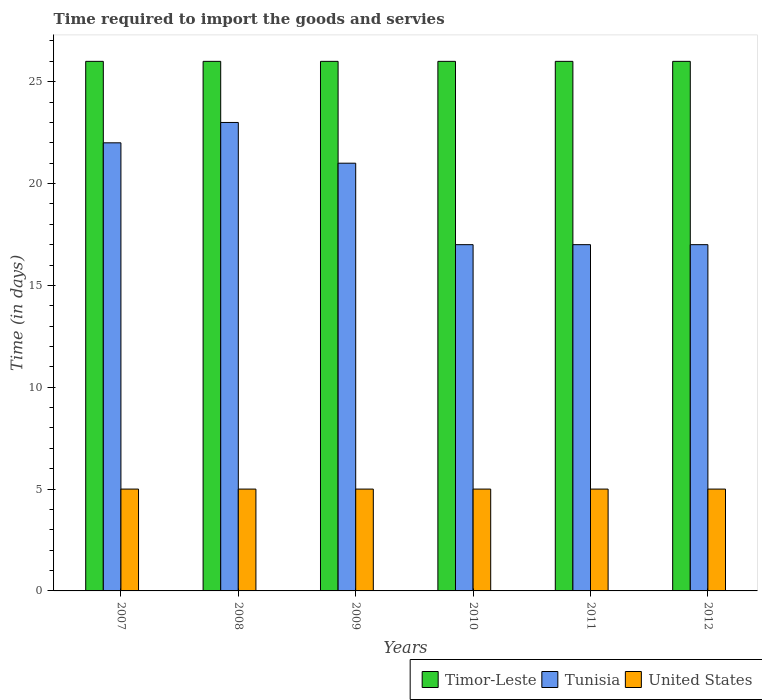How many bars are there on the 5th tick from the right?
Offer a terse response. 3. What is the label of the 1st group of bars from the left?
Ensure brevity in your answer.  2007. What is the number of days required to import the goods and services in Timor-Leste in 2010?
Your answer should be very brief. 26. Across all years, what is the maximum number of days required to import the goods and services in Tunisia?
Give a very brief answer. 23. Across all years, what is the minimum number of days required to import the goods and services in United States?
Make the answer very short. 5. In which year was the number of days required to import the goods and services in Timor-Leste maximum?
Keep it short and to the point. 2007. What is the total number of days required to import the goods and services in Tunisia in the graph?
Your answer should be compact. 117. What is the difference between the number of days required to import the goods and services in Timor-Leste in 2007 and that in 2012?
Provide a succinct answer. 0. What is the ratio of the number of days required to import the goods and services in Tunisia in 2008 to that in 2010?
Keep it short and to the point. 1.35. What is the difference between the highest and the second highest number of days required to import the goods and services in Tunisia?
Give a very brief answer. 1. In how many years, is the number of days required to import the goods and services in Timor-Leste greater than the average number of days required to import the goods and services in Timor-Leste taken over all years?
Provide a short and direct response. 0. Is the sum of the number of days required to import the goods and services in United States in 2011 and 2012 greater than the maximum number of days required to import the goods and services in Timor-Leste across all years?
Your answer should be very brief. No. What does the 2nd bar from the left in 2007 represents?
Offer a very short reply. Tunisia. What does the 3rd bar from the right in 2012 represents?
Provide a short and direct response. Timor-Leste. How many bars are there?
Your answer should be very brief. 18. Are the values on the major ticks of Y-axis written in scientific E-notation?
Your answer should be very brief. No. Does the graph contain any zero values?
Make the answer very short. No. Does the graph contain grids?
Offer a very short reply. No. How many legend labels are there?
Ensure brevity in your answer.  3. What is the title of the graph?
Offer a terse response. Time required to import the goods and servies. What is the label or title of the Y-axis?
Offer a very short reply. Time (in days). What is the Time (in days) of Timor-Leste in 2008?
Your answer should be compact. 26. What is the Time (in days) in Timor-Leste in 2009?
Provide a succinct answer. 26. What is the Time (in days) of United States in 2009?
Keep it short and to the point. 5. What is the Time (in days) of Tunisia in 2010?
Offer a terse response. 17. What is the Time (in days) in United States in 2010?
Ensure brevity in your answer.  5. What is the Time (in days) in United States in 2011?
Offer a very short reply. 5. What is the Time (in days) of United States in 2012?
Provide a short and direct response. 5. Across all years, what is the maximum Time (in days) in Timor-Leste?
Ensure brevity in your answer.  26. Across all years, what is the maximum Time (in days) in United States?
Your answer should be compact. 5. Across all years, what is the minimum Time (in days) in Timor-Leste?
Your answer should be compact. 26. What is the total Time (in days) in Timor-Leste in the graph?
Ensure brevity in your answer.  156. What is the total Time (in days) of Tunisia in the graph?
Provide a succinct answer. 117. What is the total Time (in days) in United States in the graph?
Offer a terse response. 30. What is the difference between the Time (in days) of Timor-Leste in 2007 and that in 2008?
Your answer should be compact. 0. What is the difference between the Time (in days) in Timor-Leste in 2007 and that in 2009?
Your answer should be compact. 0. What is the difference between the Time (in days) of Tunisia in 2007 and that in 2009?
Offer a very short reply. 1. What is the difference between the Time (in days) of Timor-Leste in 2007 and that in 2010?
Your answer should be very brief. 0. What is the difference between the Time (in days) of Timor-Leste in 2007 and that in 2011?
Provide a succinct answer. 0. What is the difference between the Time (in days) of Tunisia in 2007 and that in 2012?
Your response must be concise. 5. What is the difference between the Time (in days) in Timor-Leste in 2008 and that in 2009?
Your answer should be very brief. 0. What is the difference between the Time (in days) in United States in 2008 and that in 2009?
Make the answer very short. 0. What is the difference between the Time (in days) of Timor-Leste in 2008 and that in 2011?
Your answer should be very brief. 0. What is the difference between the Time (in days) of Tunisia in 2008 and that in 2011?
Your answer should be very brief. 6. What is the difference between the Time (in days) of United States in 2008 and that in 2011?
Offer a very short reply. 0. What is the difference between the Time (in days) of Tunisia in 2008 and that in 2012?
Your answer should be very brief. 6. What is the difference between the Time (in days) in United States in 2008 and that in 2012?
Provide a short and direct response. 0. What is the difference between the Time (in days) in Timor-Leste in 2009 and that in 2010?
Your answer should be compact. 0. What is the difference between the Time (in days) of United States in 2009 and that in 2011?
Your answer should be compact. 0. What is the difference between the Time (in days) of United States in 2010 and that in 2011?
Give a very brief answer. 0. What is the difference between the Time (in days) in Tunisia in 2010 and that in 2012?
Give a very brief answer. 0. What is the difference between the Time (in days) of United States in 2010 and that in 2012?
Your answer should be compact. 0. What is the difference between the Time (in days) in Tunisia in 2011 and that in 2012?
Offer a very short reply. 0. What is the difference between the Time (in days) of United States in 2011 and that in 2012?
Your response must be concise. 0. What is the difference between the Time (in days) of Timor-Leste in 2007 and the Time (in days) of United States in 2008?
Ensure brevity in your answer.  21. What is the difference between the Time (in days) in Timor-Leste in 2007 and the Time (in days) in United States in 2009?
Your response must be concise. 21. What is the difference between the Time (in days) of Tunisia in 2007 and the Time (in days) of United States in 2009?
Offer a terse response. 17. What is the difference between the Time (in days) in Timor-Leste in 2007 and the Time (in days) in Tunisia in 2010?
Offer a terse response. 9. What is the difference between the Time (in days) of Tunisia in 2007 and the Time (in days) of United States in 2010?
Your answer should be compact. 17. What is the difference between the Time (in days) in Timor-Leste in 2007 and the Time (in days) in Tunisia in 2011?
Offer a terse response. 9. What is the difference between the Time (in days) of Timor-Leste in 2007 and the Time (in days) of United States in 2011?
Provide a succinct answer. 21. What is the difference between the Time (in days) of Tunisia in 2007 and the Time (in days) of United States in 2011?
Offer a terse response. 17. What is the difference between the Time (in days) of Timor-Leste in 2007 and the Time (in days) of Tunisia in 2012?
Keep it short and to the point. 9. What is the difference between the Time (in days) of Timor-Leste in 2007 and the Time (in days) of United States in 2012?
Ensure brevity in your answer.  21. What is the difference between the Time (in days) in Timor-Leste in 2008 and the Time (in days) in Tunisia in 2009?
Keep it short and to the point. 5. What is the difference between the Time (in days) in Tunisia in 2008 and the Time (in days) in United States in 2009?
Provide a short and direct response. 18. What is the difference between the Time (in days) of Timor-Leste in 2008 and the Time (in days) of Tunisia in 2010?
Provide a succinct answer. 9. What is the difference between the Time (in days) in Timor-Leste in 2008 and the Time (in days) in Tunisia in 2012?
Keep it short and to the point. 9. What is the difference between the Time (in days) of Tunisia in 2008 and the Time (in days) of United States in 2012?
Offer a very short reply. 18. What is the difference between the Time (in days) of Timor-Leste in 2009 and the Time (in days) of Tunisia in 2010?
Offer a very short reply. 9. What is the difference between the Time (in days) in Timor-Leste in 2009 and the Time (in days) in United States in 2010?
Keep it short and to the point. 21. What is the difference between the Time (in days) in Tunisia in 2009 and the Time (in days) in United States in 2010?
Ensure brevity in your answer.  16. What is the difference between the Time (in days) of Timor-Leste in 2009 and the Time (in days) of Tunisia in 2011?
Your answer should be very brief. 9. What is the difference between the Time (in days) of Timor-Leste in 2009 and the Time (in days) of United States in 2011?
Keep it short and to the point. 21. What is the difference between the Time (in days) of Timor-Leste in 2009 and the Time (in days) of Tunisia in 2012?
Your answer should be very brief. 9. What is the difference between the Time (in days) of Tunisia in 2009 and the Time (in days) of United States in 2012?
Make the answer very short. 16. What is the difference between the Time (in days) in Timor-Leste in 2010 and the Time (in days) in Tunisia in 2011?
Your answer should be compact. 9. What is the difference between the Time (in days) of Tunisia in 2010 and the Time (in days) of United States in 2011?
Your answer should be very brief. 12. What is the difference between the Time (in days) of Timor-Leste in 2010 and the Time (in days) of Tunisia in 2012?
Ensure brevity in your answer.  9. What is the difference between the Time (in days) of Timor-Leste in 2010 and the Time (in days) of United States in 2012?
Keep it short and to the point. 21. What is the difference between the Time (in days) in Timor-Leste in 2011 and the Time (in days) in Tunisia in 2012?
Ensure brevity in your answer.  9. What is the difference between the Time (in days) in Timor-Leste in 2011 and the Time (in days) in United States in 2012?
Make the answer very short. 21. In the year 2007, what is the difference between the Time (in days) of Tunisia and Time (in days) of United States?
Your answer should be very brief. 17. In the year 2008, what is the difference between the Time (in days) in Timor-Leste and Time (in days) in Tunisia?
Your answer should be compact. 3. In the year 2011, what is the difference between the Time (in days) in Timor-Leste and Time (in days) in Tunisia?
Provide a succinct answer. 9. In the year 2012, what is the difference between the Time (in days) in Tunisia and Time (in days) in United States?
Offer a very short reply. 12. What is the ratio of the Time (in days) of Tunisia in 2007 to that in 2008?
Your answer should be compact. 0.96. What is the ratio of the Time (in days) of United States in 2007 to that in 2008?
Make the answer very short. 1. What is the ratio of the Time (in days) of Tunisia in 2007 to that in 2009?
Offer a terse response. 1.05. What is the ratio of the Time (in days) in Timor-Leste in 2007 to that in 2010?
Ensure brevity in your answer.  1. What is the ratio of the Time (in days) in Tunisia in 2007 to that in 2010?
Give a very brief answer. 1.29. What is the ratio of the Time (in days) of Tunisia in 2007 to that in 2011?
Offer a very short reply. 1.29. What is the ratio of the Time (in days) in Timor-Leste in 2007 to that in 2012?
Ensure brevity in your answer.  1. What is the ratio of the Time (in days) of Tunisia in 2007 to that in 2012?
Keep it short and to the point. 1.29. What is the ratio of the Time (in days) in United States in 2007 to that in 2012?
Provide a short and direct response. 1. What is the ratio of the Time (in days) in Timor-Leste in 2008 to that in 2009?
Ensure brevity in your answer.  1. What is the ratio of the Time (in days) of Tunisia in 2008 to that in 2009?
Offer a terse response. 1.1. What is the ratio of the Time (in days) in United States in 2008 to that in 2009?
Offer a very short reply. 1. What is the ratio of the Time (in days) in Timor-Leste in 2008 to that in 2010?
Your answer should be very brief. 1. What is the ratio of the Time (in days) in Tunisia in 2008 to that in 2010?
Your answer should be very brief. 1.35. What is the ratio of the Time (in days) of United States in 2008 to that in 2010?
Give a very brief answer. 1. What is the ratio of the Time (in days) in Timor-Leste in 2008 to that in 2011?
Keep it short and to the point. 1. What is the ratio of the Time (in days) of Tunisia in 2008 to that in 2011?
Your answer should be compact. 1.35. What is the ratio of the Time (in days) in Tunisia in 2008 to that in 2012?
Your answer should be compact. 1.35. What is the ratio of the Time (in days) of Tunisia in 2009 to that in 2010?
Your answer should be very brief. 1.24. What is the ratio of the Time (in days) of Timor-Leste in 2009 to that in 2011?
Keep it short and to the point. 1. What is the ratio of the Time (in days) in Tunisia in 2009 to that in 2011?
Give a very brief answer. 1.24. What is the ratio of the Time (in days) of United States in 2009 to that in 2011?
Provide a succinct answer. 1. What is the ratio of the Time (in days) of Timor-Leste in 2009 to that in 2012?
Offer a very short reply. 1. What is the ratio of the Time (in days) in Tunisia in 2009 to that in 2012?
Your response must be concise. 1.24. What is the ratio of the Time (in days) of Tunisia in 2010 to that in 2011?
Your answer should be compact. 1. What is the ratio of the Time (in days) in Timor-Leste in 2010 to that in 2012?
Your answer should be very brief. 1. What is the ratio of the Time (in days) of Tunisia in 2010 to that in 2012?
Provide a succinct answer. 1. What is the ratio of the Time (in days) of United States in 2011 to that in 2012?
Offer a very short reply. 1. What is the difference between the highest and the lowest Time (in days) in Timor-Leste?
Your answer should be very brief. 0. What is the difference between the highest and the lowest Time (in days) in Tunisia?
Keep it short and to the point. 6. 